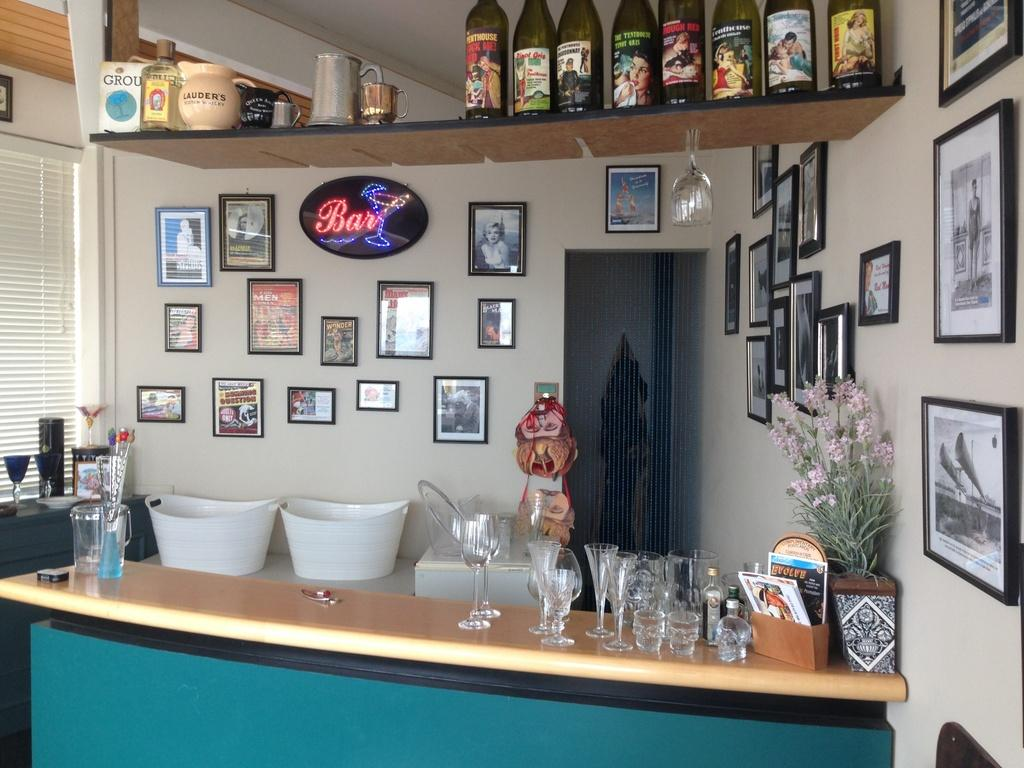<image>
Write a terse but informative summary of the picture. A home bar is in a corner and has a "bar" sign on the wall behind it. 